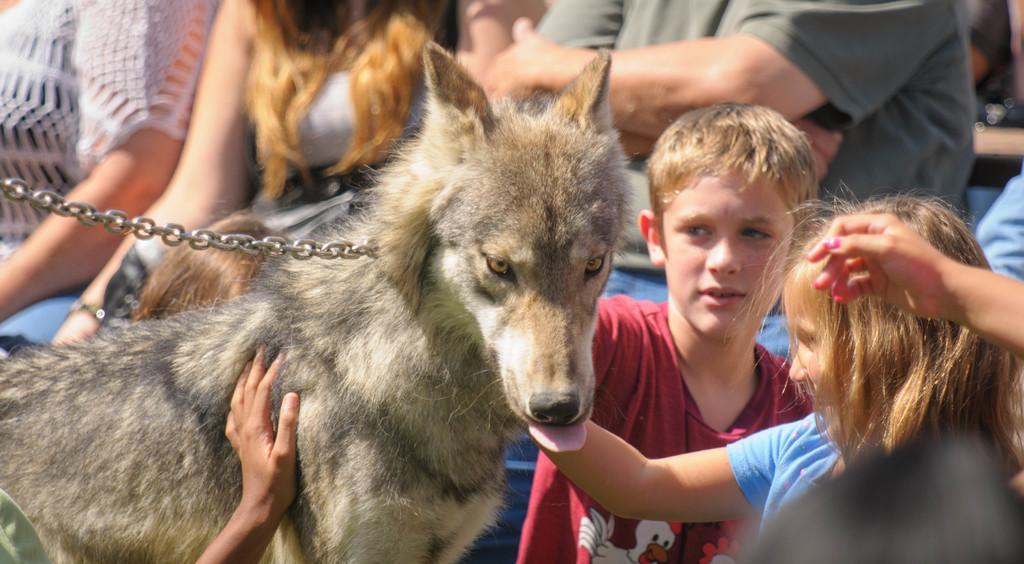Can you describe this image briefly? In the image there is a dog, on right side of the image we can also see two kids are holding a dog in background group of people sitting on chair. 